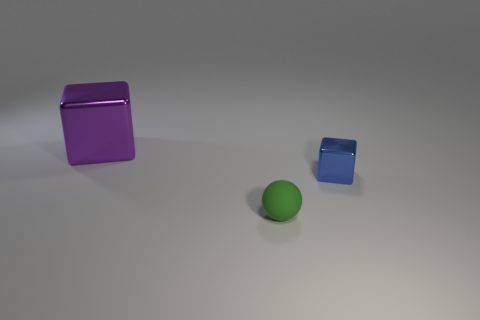Are there any other things that are the same size as the purple block?
Offer a terse response. No. What number of large objects are blue matte spheres or blue blocks?
Your answer should be compact. 0. There is a thing that is left of the rubber sphere; does it have the same shape as the shiny object right of the small green rubber ball?
Ensure brevity in your answer.  Yes. There is a cube that is to the left of the tiny shiny thing on the right side of the big metal thing that is left of the tiny green rubber sphere; how big is it?
Ensure brevity in your answer.  Large. How big is the shiny block to the left of the green thing?
Provide a short and direct response. Large. There is a tiny thing behind the ball; what material is it?
Provide a succinct answer. Metal. What number of green objects are either large objects or small metallic cylinders?
Keep it short and to the point. 0. Are the purple cube and the tiny object to the right of the green rubber ball made of the same material?
Your answer should be compact. Yes. Are there the same number of blue objects behind the blue object and tiny green matte spheres that are to the right of the matte object?
Keep it short and to the point. Yes. Is the size of the purple object the same as the metal cube right of the large purple metal thing?
Give a very brief answer. No. 